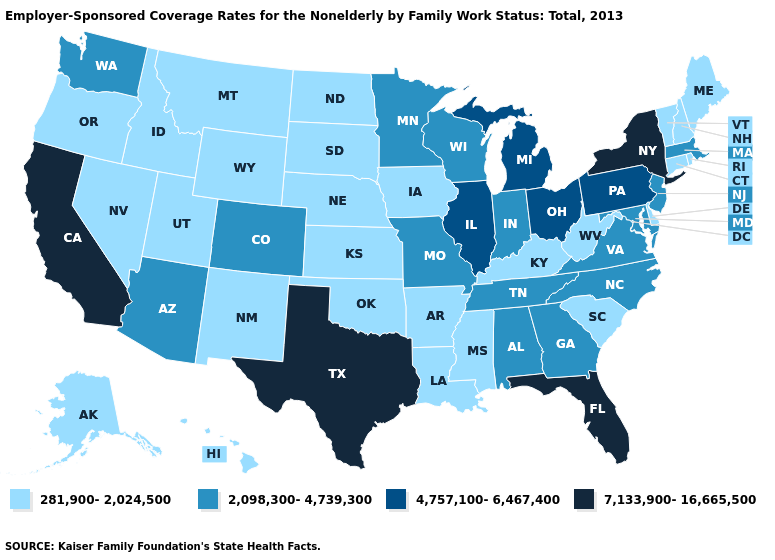Name the states that have a value in the range 281,900-2,024,500?
Be succinct. Alaska, Arkansas, Connecticut, Delaware, Hawaii, Idaho, Iowa, Kansas, Kentucky, Louisiana, Maine, Mississippi, Montana, Nebraska, Nevada, New Hampshire, New Mexico, North Dakota, Oklahoma, Oregon, Rhode Island, South Carolina, South Dakota, Utah, Vermont, West Virginia, Wyoming. Name the states that have a value in the range 2,098,300-4,739,300?
Write a very short answer. Alabama, Arizona, Colorado, Georgia, Indiana, Maryland, Massachusetts, Minnesota, Missouri, New Jersey, North Carolina, Tennessee, Virginia, Washington, Wisconsin. Name the states that have a value in the range 2,098,300-4,739,300?
Quick response, please. Alabama, Arizona, Colorado, Georgia, Indiana, Maryland, Massachusetts, Minnesota, Missouri, New Jersey, North Carolina, Tennessee, Virginia, Washington, Wisconsin. Does the map have missing data?
Keep it brief. No. What is the highest value in the West ?
Be succinct. 7,133,900-16,665,500. Does Vermont have the same value as New Hampshire?
Give a very brief answer. Yes. Does Oklahoma have the same value as California?
Be succinct. No. Does North Carolina have the highest value in the South?
Answer briefly. No. Name the states that have a value in the range 281,900-2,024,500?
Keep it brief. Alaska, Arkansas, Connecticut, Delaware, Hawaii, Idaho, Iowa, Kansas, Kentucky, Louisiana, Maine, Mississippi, Montana, Nebraska, Nevada, New Hampshire, New Mexico, North Dakota, Oklahoma, Oregon, Rhode Island, South Carolina, South Dakota, Utah, Vermont, West Virginia, Wyoming. Name the states that have a value in the range 4,757,100-6,467,400?
Keep it brief. Illinois, Michigan, Ohio, Pennsylvania. Among the states that border Utah , which have the highest value?
Keep it brief. Arizona, Colorado. Does Oregon have the lowest value in the West?
Quick response, please. Yes. Among the states that border Maryland , which have the lowest value?
Give a very brief answer. Delaware, West Virginia. How many symbols are there in the legend?
Short answer required. 4. Does Alaska have the same value as Louisiana?
Keep it brief. Yes. 